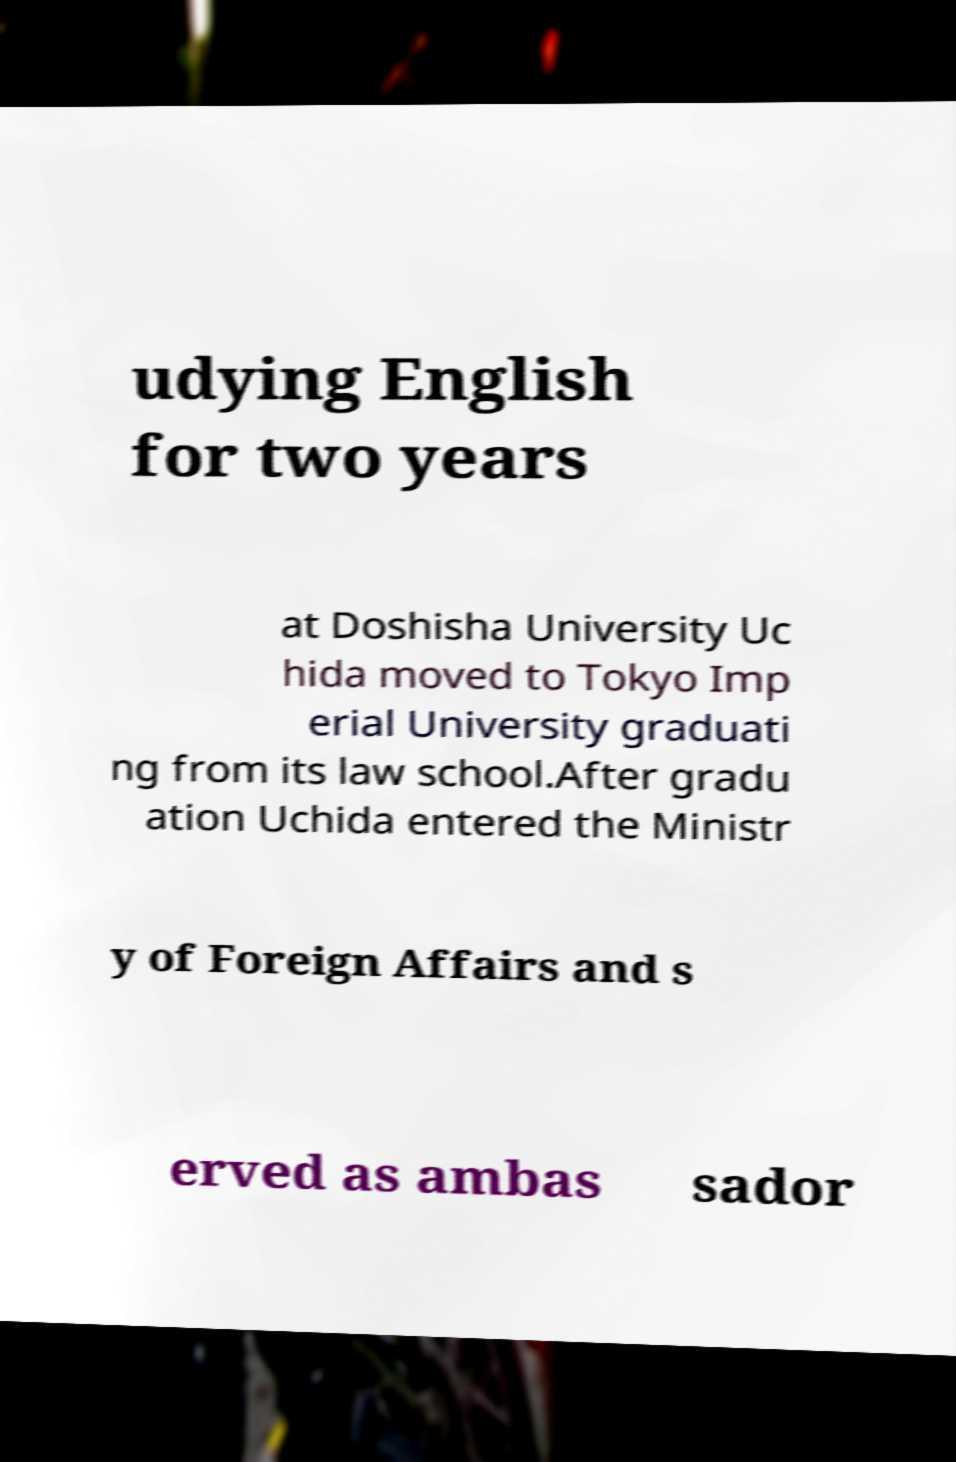Please identify and transcribe the text found in this image. udying English for two years at Doshisha University Uc hida moved to Tokyo Imp erial University graduati ng from its law school.After gradu ation Uchida entered the Ministr y of Foreign Affairs and s erved as ambas sador 